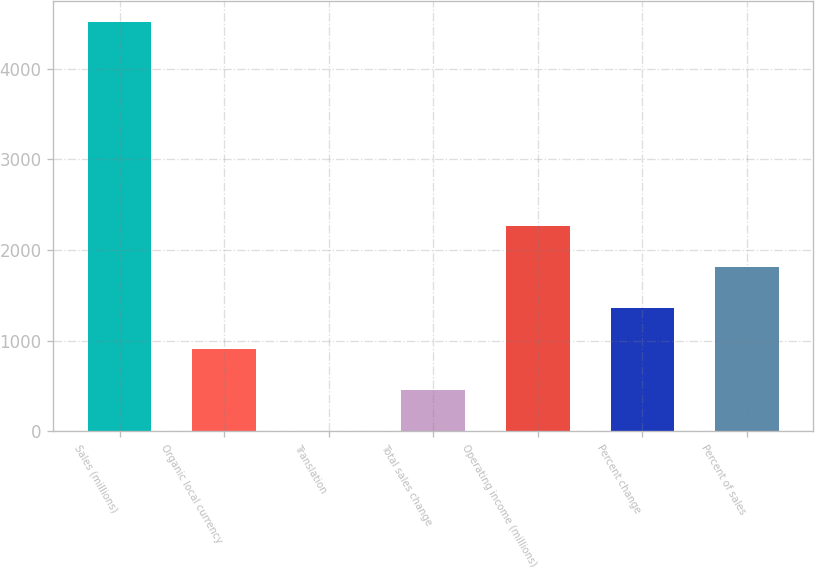Convert chart to OTSL. <chart><loc_0><loc_0><loc_500><loc_500><bar_chart><fcel>Sales (millions)<fcel>Organic local currency<fcel>Translation<fcel>Total sales change<fcel>Operating income (millions)<fcel>Percent change<fcel>Percent of sales<nl><fcel>4523<fcel>906.04<fcel>1.8<fcel>453.92<fcel>2262.4<fcel>1358.16<fcel>1810.28<nl></chart> 